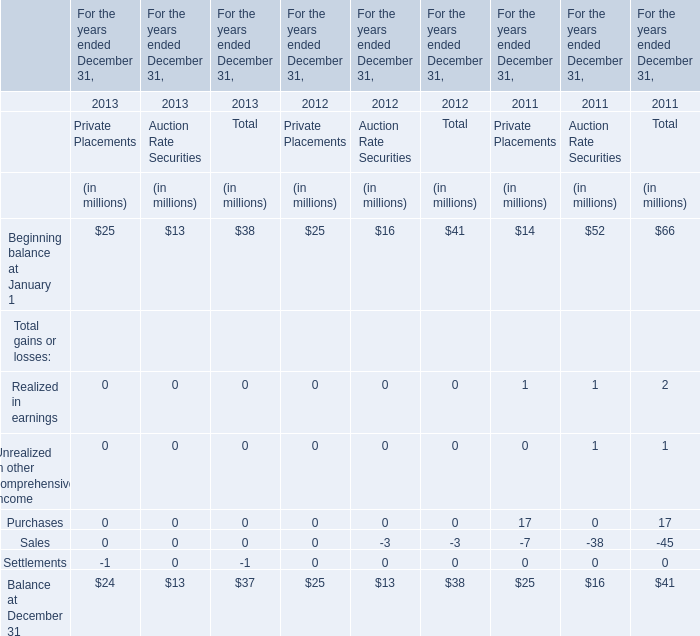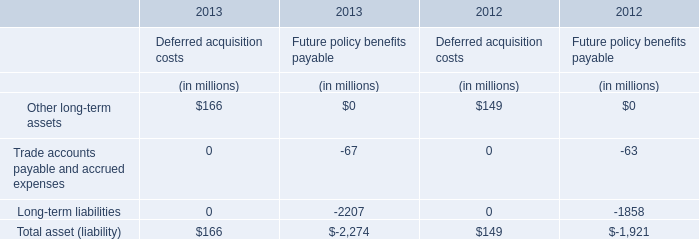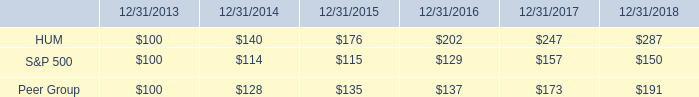what was the percent of the of the growth for stock total return performance for hum from 2016 to 2017 
Computations: ((247 - 202) / 202)
Answer: 0.22277. 